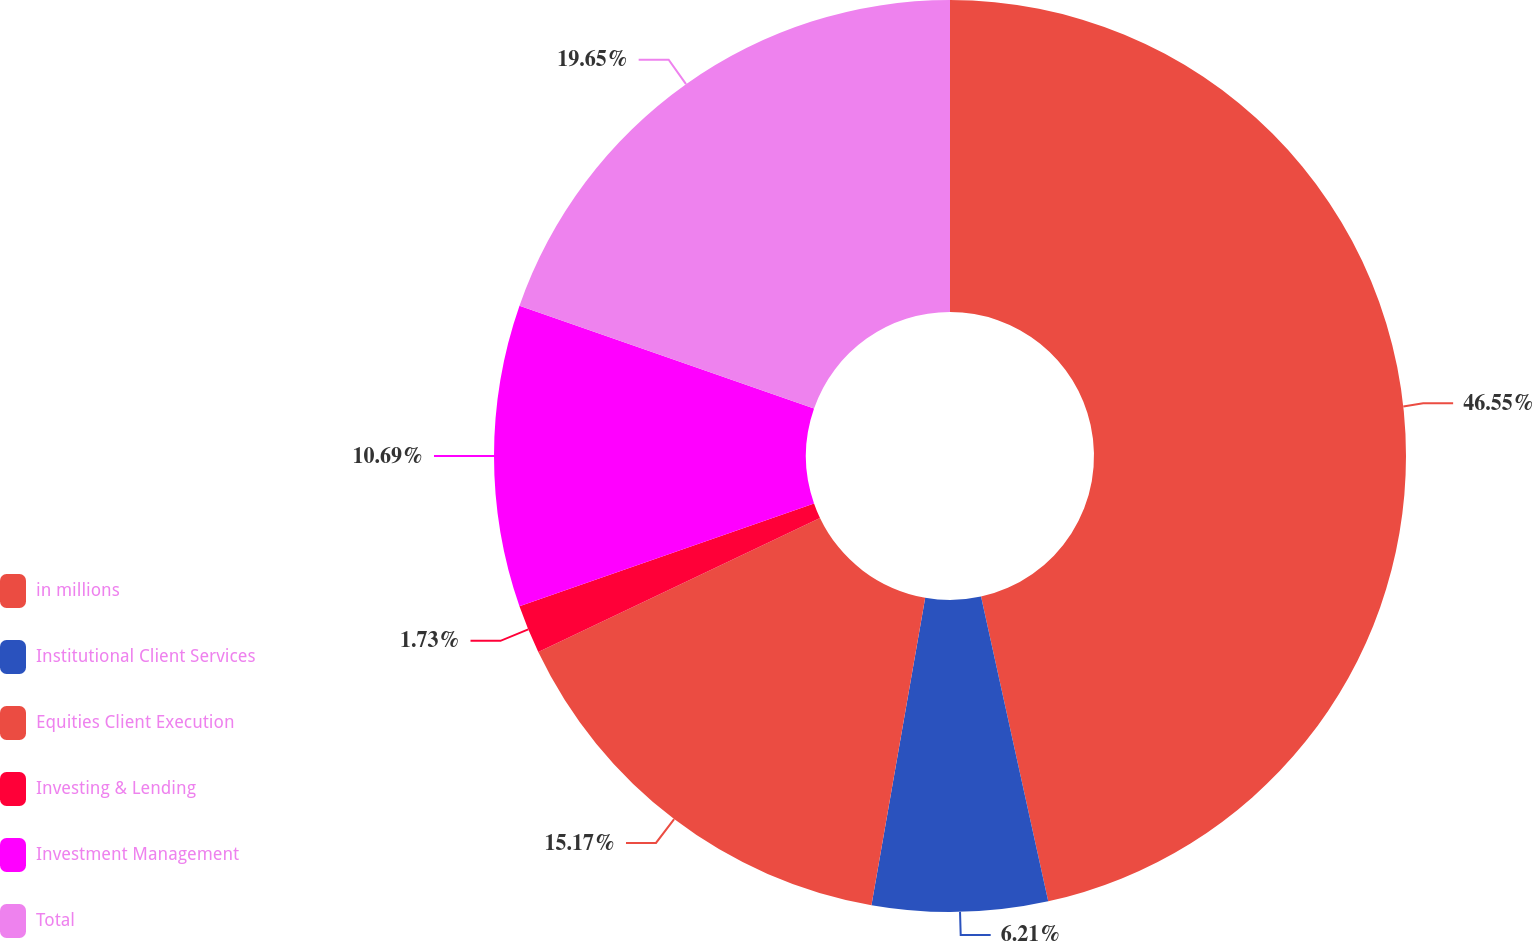Convert chart to OTSL. <chart><loc_0><loc_0><loc_500><loc_500><pie_chart><fcel>in millions<fcel>Institutional Client Services<fcel>Equities Client Execution<fcel>Investing & Lending<fcel>Investment Management<fcel>Total<nl><fcel>46.54%<fcel>6.21%<fcel>15.17%<fcel>1.73%<fcel>10.69%<fcel>19.65%<nl></chart> 